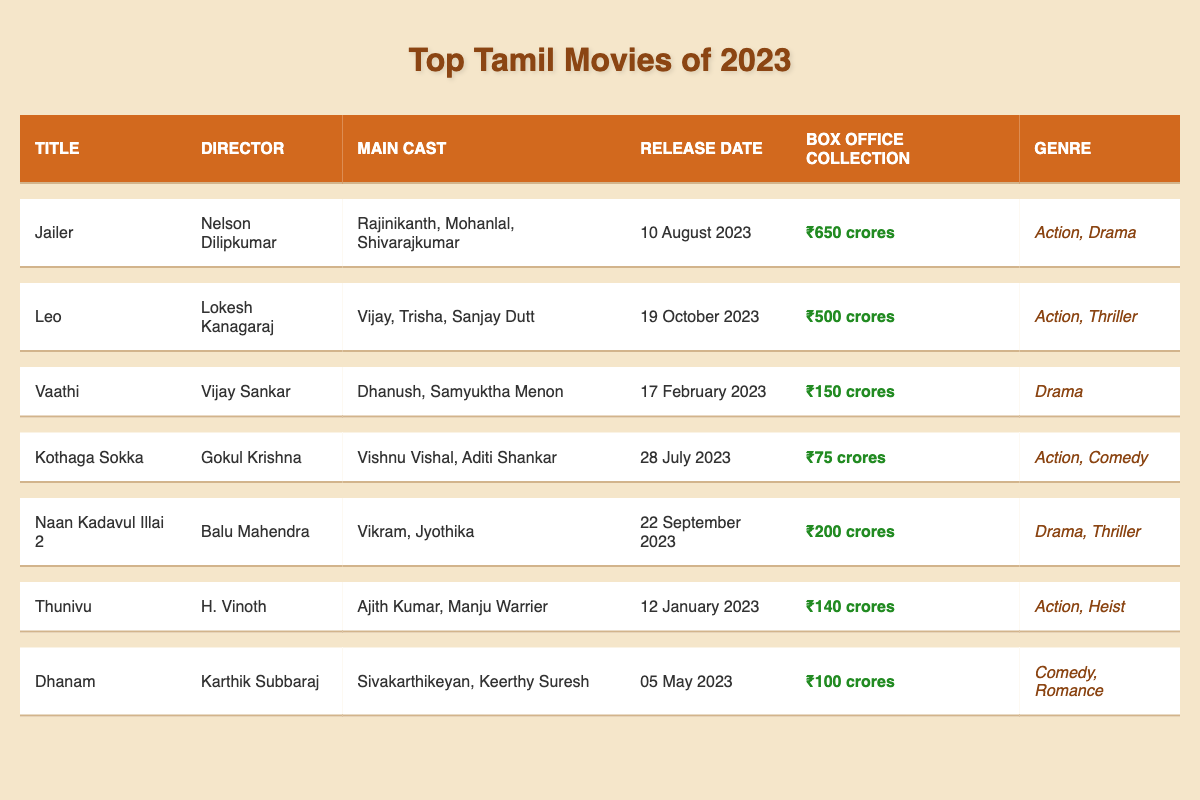What is the box office collection of "Jailer"? The table shows that the box office collection for "Jailer" is listed as ₹650 crores.
Answer: ₹650 crores Who directed the movie "Leo"? According to the table, "Leo" was directed by Lokesh Kanagaraj.
Answer: Lokesh Kanagaraj What genre is "Vaathi"? The genre for "Vaathi" is mentioned as Drama in the table.
Answer: Drama Which movie collected the least at the box office? The table shows that "Kothaga Sokka" has the lowest box office collection of ₹75 crores compared to others.
Answer: Kothaga Sokka On what date was "Naan Kadavul Illai 2" released? The release date for "Naan Kadavul Illai 2" is shown as 22 September 2023 in the table.
Answer: 22 September 2023 What is the total box office collection for "Thunivu" and "Dhanam"? From the table, "Thunivu" collected ₹140 crores and "Dhanam" collected ₹100 crores. The total is ₹140 crores + ₹100 crores = ₹240 crores.
Answer: ₹240 crores Did "Leo" exceed ₹400 crores in box office collection? Since "Leo" has a box office collection of ₹500 crores, which is greater than ₹400 crores, the answer is yes.
Answer: Yes Which movie has the highest box office collection and genre? The highest collection is from "Jailer" with ₹650 crores in the Action, Drama genre, as seen in the table.
Answer: Jailer; Action, Drama How many movies in the list have a box office collection over ₹200 crores? Based on the table, the movies are "Jailer" (₹650), "Leo" (₹500), and "Naan Kadavul Illai 2" (₹200). This gives us a total of three movies.
Answer: 3 What is the average box office collection for the movies listed in the table? The total box office collection is ₹650 + ₹500 + ₹150 + ₹75 + ₹200 + ₹140 + ₹100 = ₹1,815 crores, and there are 7 movies. The average is ₹1,815/7 = ₹259.29 crores.
Answer: ₹259.29 crores 